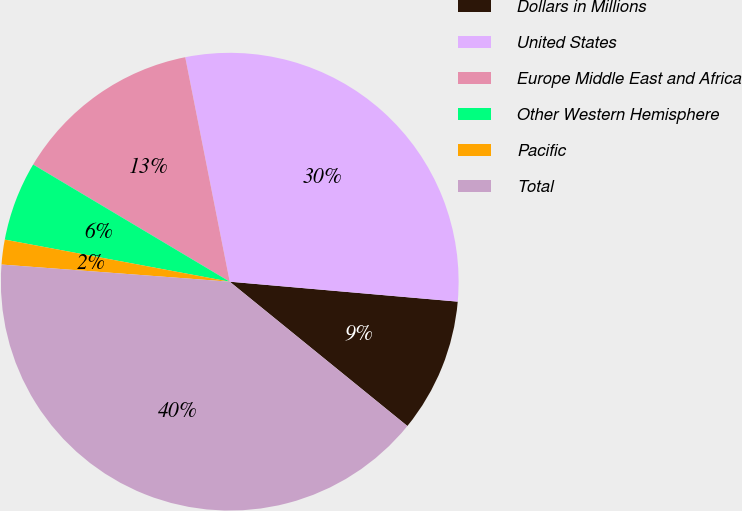Convert chart to OTSL. <chart><loc_0><loc_0><loc_500><loc_500><pie_chart><fcel>Dollars in Millions<fcel>United States<fcel>Europe Middle East and Africa<fcel>Other Western Hemisphere<fcel>Pacific<fcel>Total<nl><fcel>9.47%<fcel>29.5%<fcel>13.33%<fcel>5.61%<fcel>1.75%<fcel>40.33%<nl></chart> 